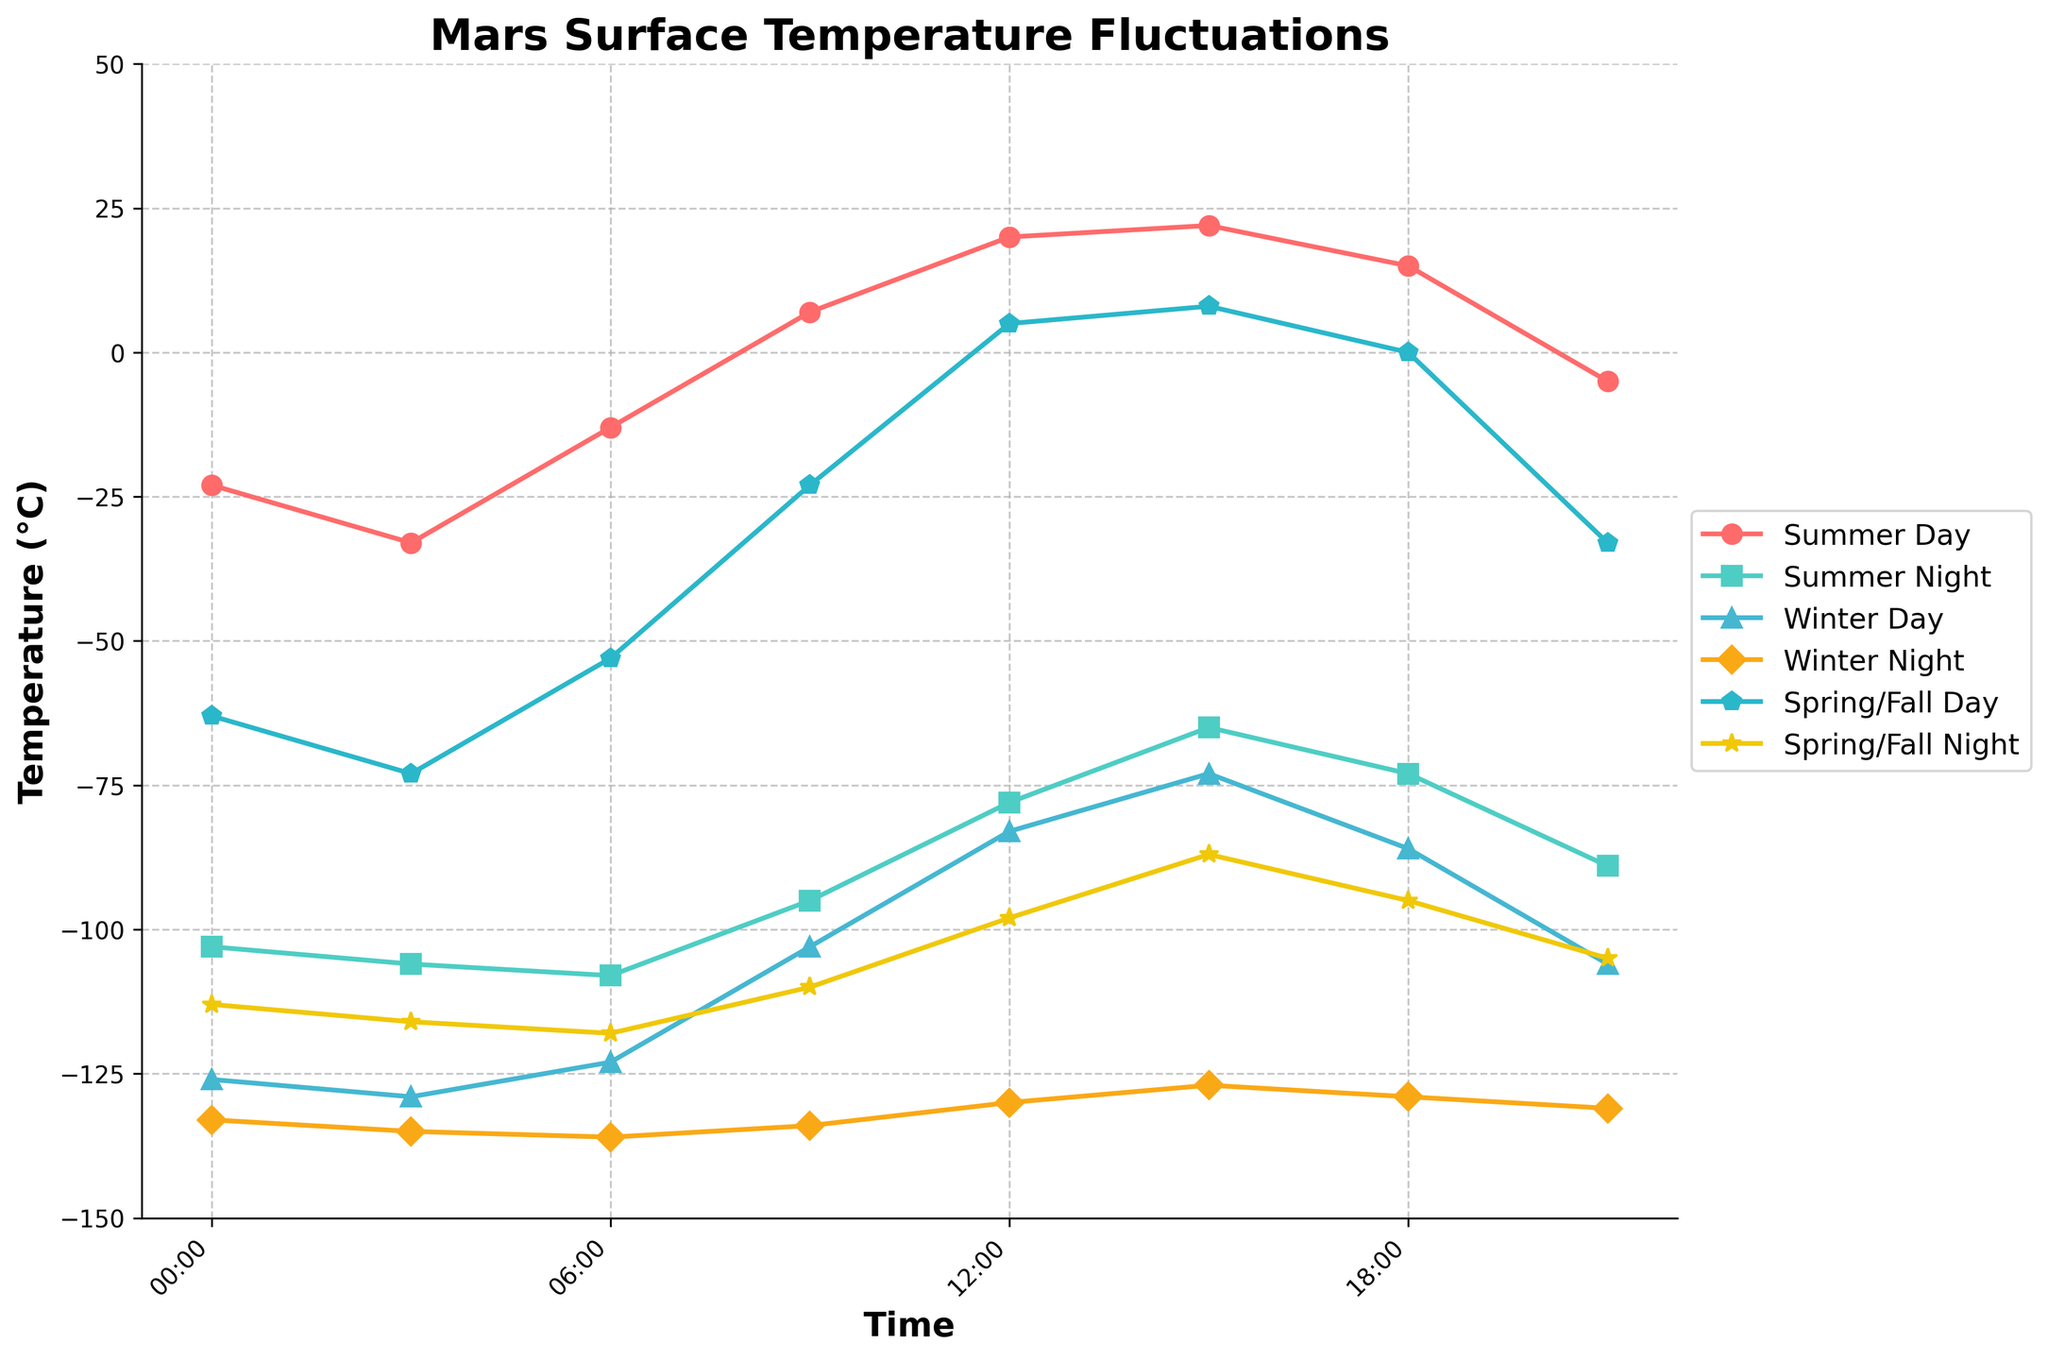What time of day has the highest temperature in the Winter Day cycle? Look at the Winter Day cycle line on the plot. The highest point is at 00:00.
Answer: 00:00 Which season shows the steepest temperature increase from night to day cycle? Compare the slopes of each season's night to day transition. The steepest rise appears in the Summer Day/Night cycle.
Answer: Summer At 15:00, what is the difference in temperature between Summer Day and Winter Day? Find the temperature values for Summer Day (22) and Winter Day (-73) at 15:00. Calculate the difference: 22 - (-73) = 95.
Answer: 95 Among the night temperatures, which season has the warmest temperature at 00:00? Compare the night temperature at 00:00 for all seasons. The warmest is from Summer Night (-103).
Answer: Summer Night What is the average daytime temperature at 12:00 across all seasons? Sum the temperatures at 12:00 for Summer Day (20), Winter Day (-83), and Spring/Fall Day (5). Divide by 3: (20 + (-83) + 5)/3 = -19.33.
Answer: -19.33 Between 12:00 and 18:00, which season experiences the most temperature drop? Compare the temperature drop for each season's day cycle: Summer Day (20 to 15 = 5), Winter Day (-83 to -86 = 3), Spring/Fall Day (5 to 0 = 5). Summer and Spring/Fall have the most significant drop of 5°C.
Answer: Summer & Spring/Fall What is the temperature range (difference between highest and lowest temperatures) in the Spring/Fall Day cycle? Find the highest (8 at 15:00) and lowest (-33 at 21:00) temperatures in Spring/Fall Day cycle. Calculate the range: 8 - (-33) = 41.
Answer: 41 How does Winter Night temperature at 12:00 compare to Summer Night temperature at 18:00? Compare -130 (Winter Night at 12:00) with -73 (Summer Night at 18:00). Winter Night is significantly colder.
Answer: Winter Night is colder Which two times show the smallest temperature difference in the Summer Day cycle? Compare the differences between temperatures at consecutive times. The smallest difference is between 12:00 (20) and 15:00 (22), a difference of 2.
Answer: 12:00 and 15:00 At what time is the temperature the same in both Summer Day and Spring/Fall Day cycles? Compare temperatures at each hour in Summer Day and Spring/Fall Day. The same temperature is at 15:00 (both are 22).
Answer: 15:00 